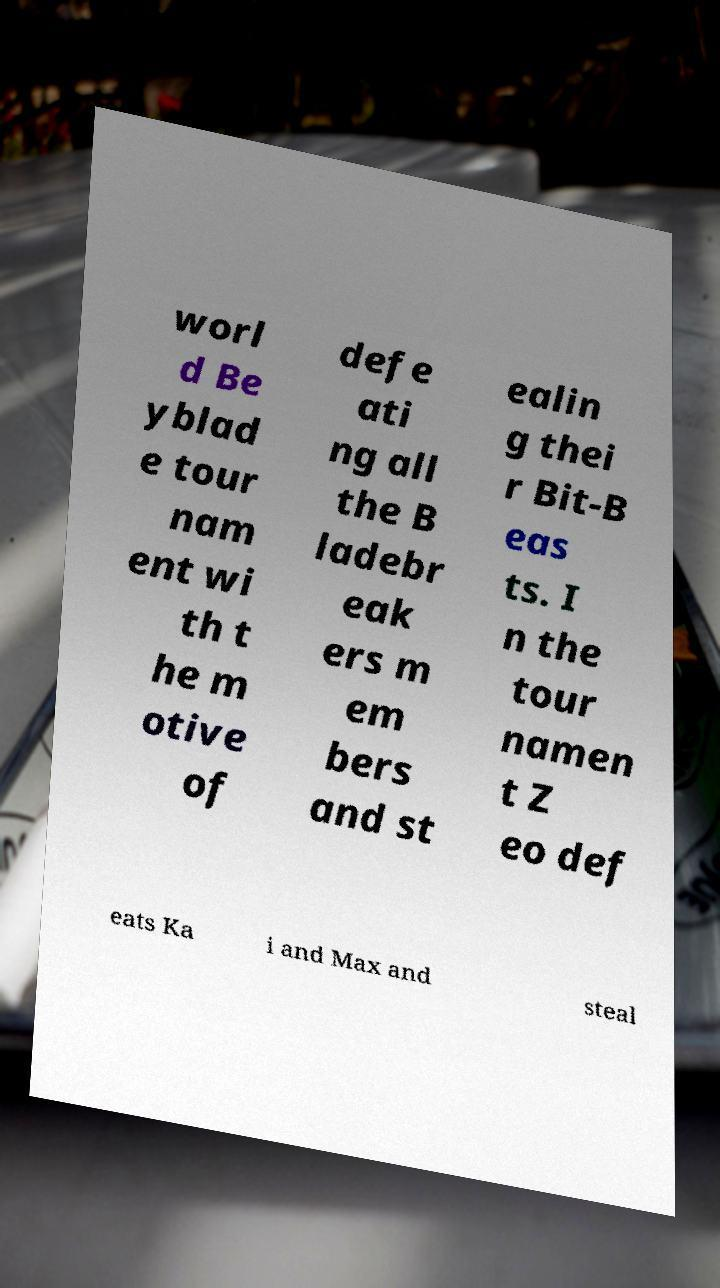Can you read and provide the text displayed in the image?This photo seems to have some interesting text. Can you extract and type it out for me? worl d Be yblad e tour nam ent wi th t he m otive of defe ati ng all the B ladebr eak ers m em bers and st ealin g thei r Bit-B eas ts. I n the tour namen t Z eo def eats Ka i and Max and steal 